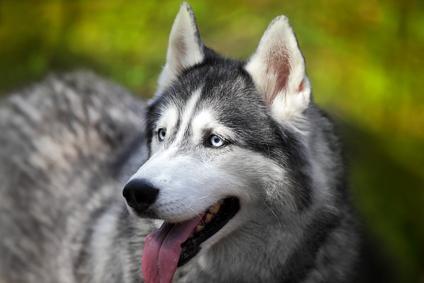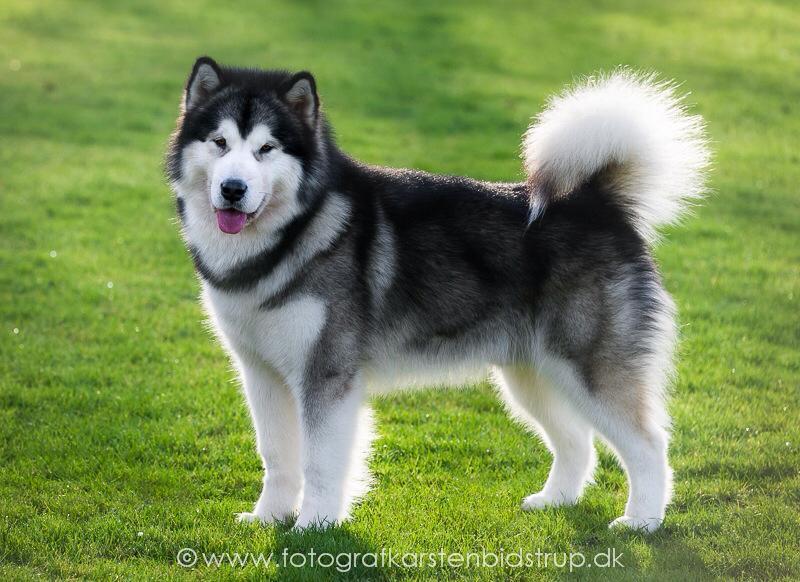The first image is the image on the left, the second image is the image on the right. Considering the images on both sides, is "Both dogs have their tongues out." valid? Answer yes or no. Yes. The first image is the image on the left, the second image is the image on the right. For the images shown, is this caption "The dog in the image on the left has its tail up and curled over its back." true? Answer yes or no. No. 